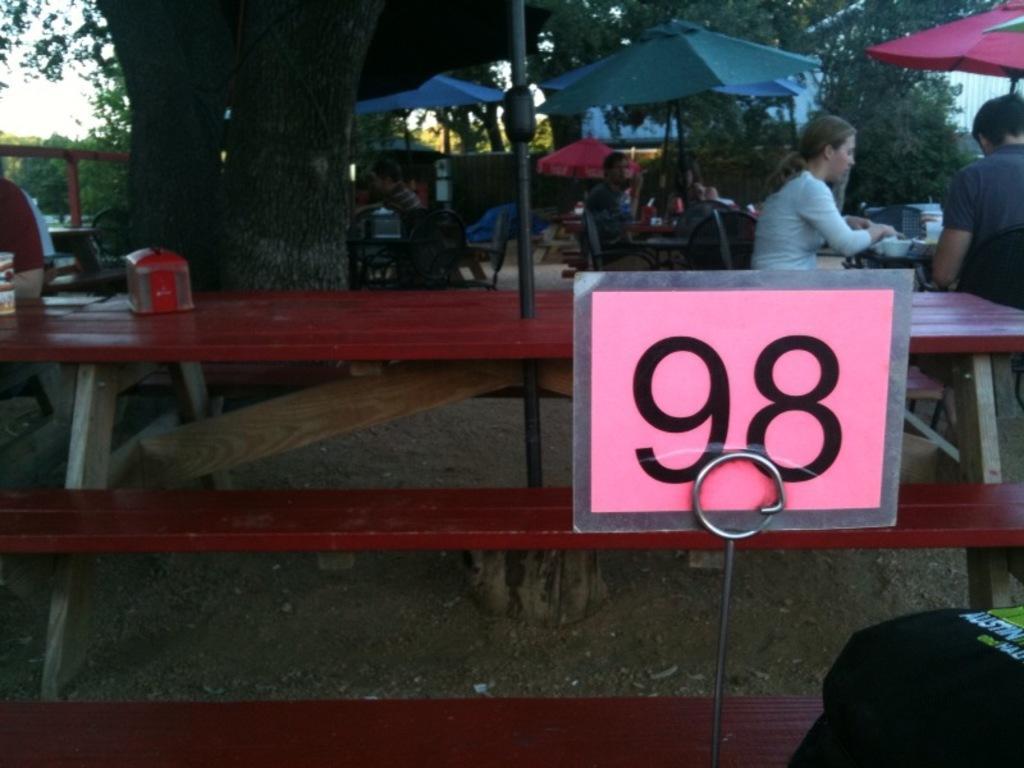How would you summarize this image in a sentence or two? In this image i can see group of people sitting on the chair there is bowl on the table,there is a umbrella and a board. At the background i can see a tree and a sky. 